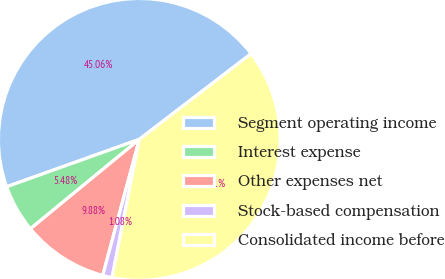<chart> <loc_0><loc_0><loc_500><loc_500><pie_chart><fcel>Segment operating income<fcel>Interest expense<fcel>Other expenses net<fcel>Stock-based compensation<fcel>Consolidated income before<nl><fcel>45.06%<fcel>5.48%<fcel>9.88%<fcel>1.08%<fcel>38.51%<nl></chart> 